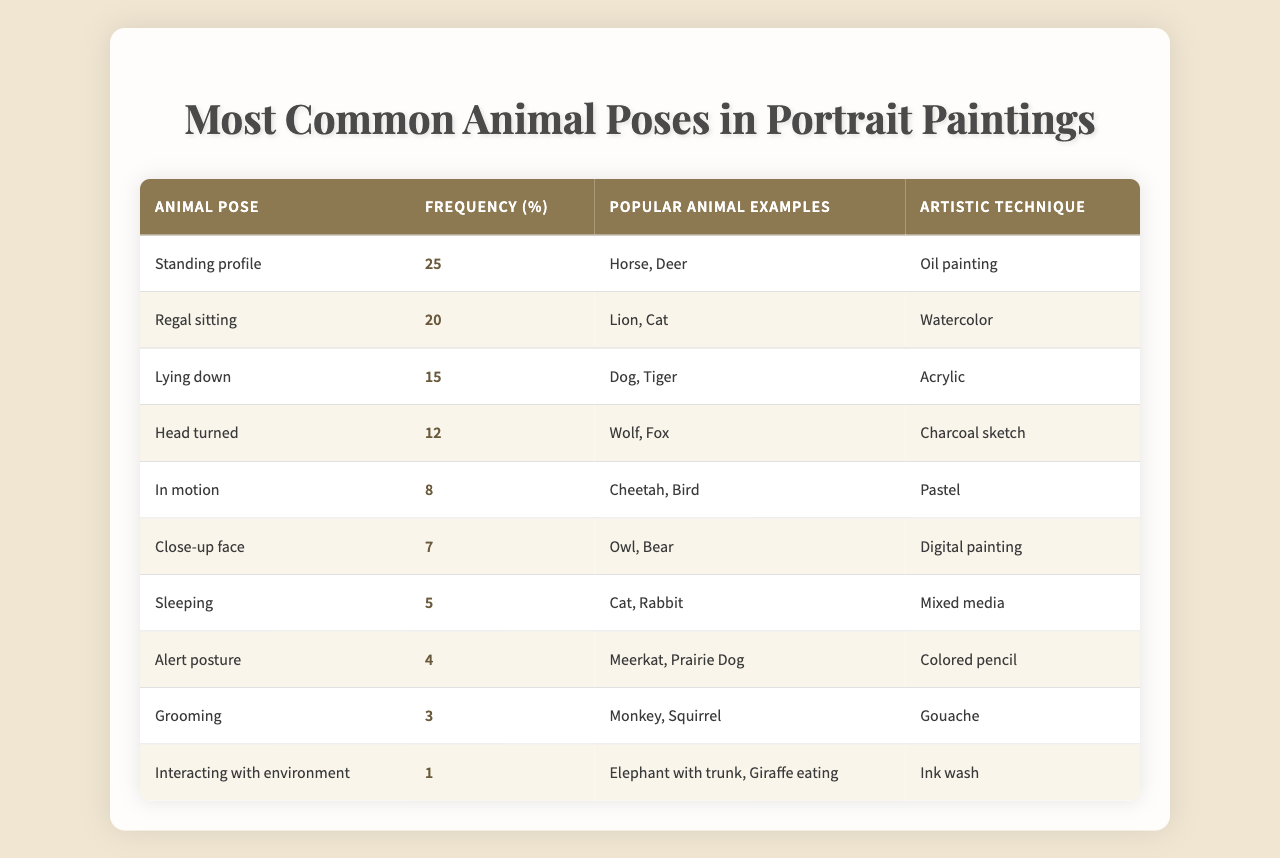What is the most common animal pose in portrait paintings? The table shows "Standing profile" with a frequency of 25%, making it the most common animal pose.
Answer: Standing profile Which artistic technique is associated with the "Regal sitting" pose? The table lists "Regal sitting" with "Watercolor" as its corresponding artistic technique.
Answer: Watercolor What percentage of animal poses in the table is represented by "Sleeping"? According to the table, "Sleeping" has a frequency of 5%, which is its percentage representation.
Answer: 5% What pose has the least frequency and how much is it? The table indicates "Elephant with trunk, Giraffe eating" under "Interacting with environment," which has a frequency of 1%.
Answer: 1% Which pose is used for the highest percentage comparison between "Grooming" and "Close-up face"? "Grooming" has a frequency of 4% while "Close-up face" has a frequency of 7%, making "Close-up face" the higher percentage.
Answer: Close-up face What is the frequency difference between "In motion" and "Lying down"? "In motion" has a frequency of 8% and "Lying down" has a frequency of 15%, so the difference is 15% - 8% = 7%.
Answer: 7% Which two animal poses combined represent approximately 50% of the table? "Standing profile" (25%) and "Regal sitting" (20%) add up to 45%, while "Lying down" brings it to 60%. Therefore, "Standing profile" and "Regal sitting" are close but do not reach 50% when combined.
Answer: Not applicable Is "Head turned" the second most common pose? "Head turned" has a frequency of 12%, which is not the second highest; "Regal sitting" (20%) holds that position.
Answer: No Which artistic technique is the least mentioned in relation to the poses? The table indicates that "Ink wash" is the least frequently associated technique as it is tied with "1" mention, given to "Interacting with the environment."
Answer: Ink wash How many animal poses have a frequency of more than 10%? The poses with more than 10% frequency are "Standing profile" (25%), "Regal sitting" (20%), "Lying down" (15%), and "Head turned" (12%). Thus, there are 4 poses.
Answer: 4 